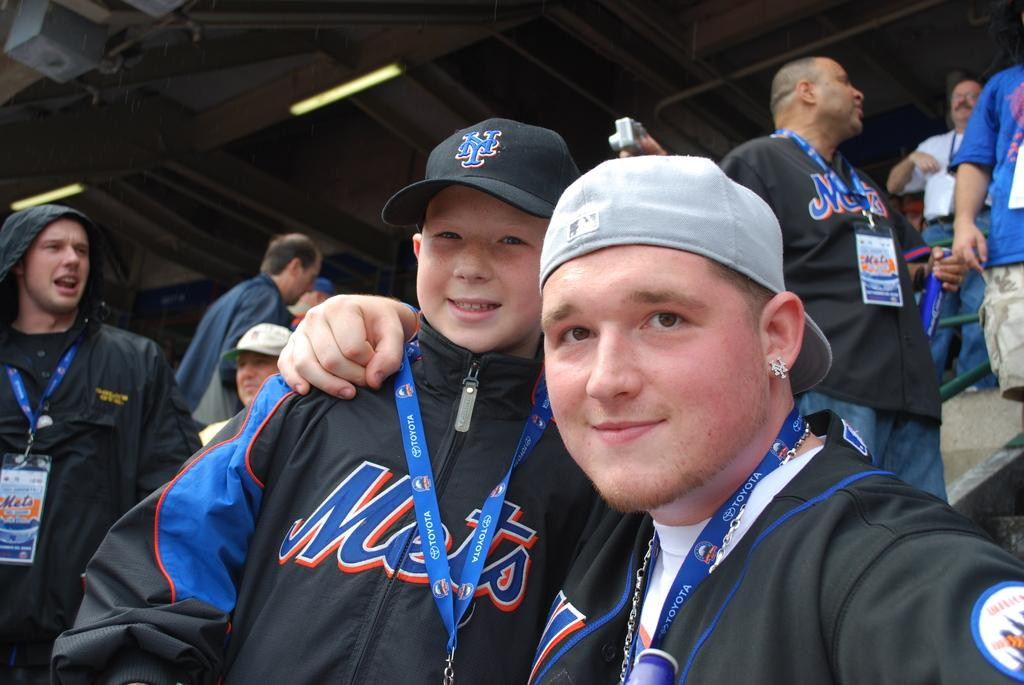<image>
Present a compact description of the photo's key features. Young fans with ball caps and sweatshirt with Mets across the front. 